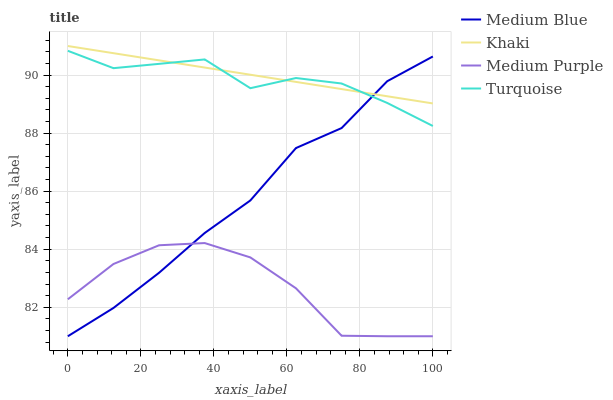Does Medium Purple have the minimum area under the curve?
Answer yes or no. Yes. Does Khaki have the maximum area under the curve?
Answer yes or no. Yes. Does Turquoise have the minimum area under the curve?
Answer yes or no. No. Does Turquoise have the maximum area under the curve?
Answer yes or no. No. Is Khaki the smoothest?
Answer yes or no. Yes. Is Medium Purple the roughest?
Answer yes or no. Yes. Is Turquoise the smoothest?
Answer yes or no. No. Is Turquoise the roughest?
Answer yes or no. No. Does Medium Purple have the lowest value?
Answer yes or no. Yes. Does Turquoise have the lowest value?
Answer yes or no. No. Does Khaki have the highest value?
Answer yes or no. Yes. Does Turquoise have the highest value?
Answer yes or no. No. Is Medium Purple less than Khaki?
Answer yes or no. Yes. Is Khaki greater than Medium Purple?
Answer yes or no. Yes. Does Medium Purple intersect Medium Blue?
Answer yes or no. Yes. Is Medium Purple less than Medium Blue?
Answer yes or no. No. Is Medium Purple greater than Medium Blue?
Answer yes or no. No. Does Medium Purple intersect Khaki?
Answer yes or no. No. 